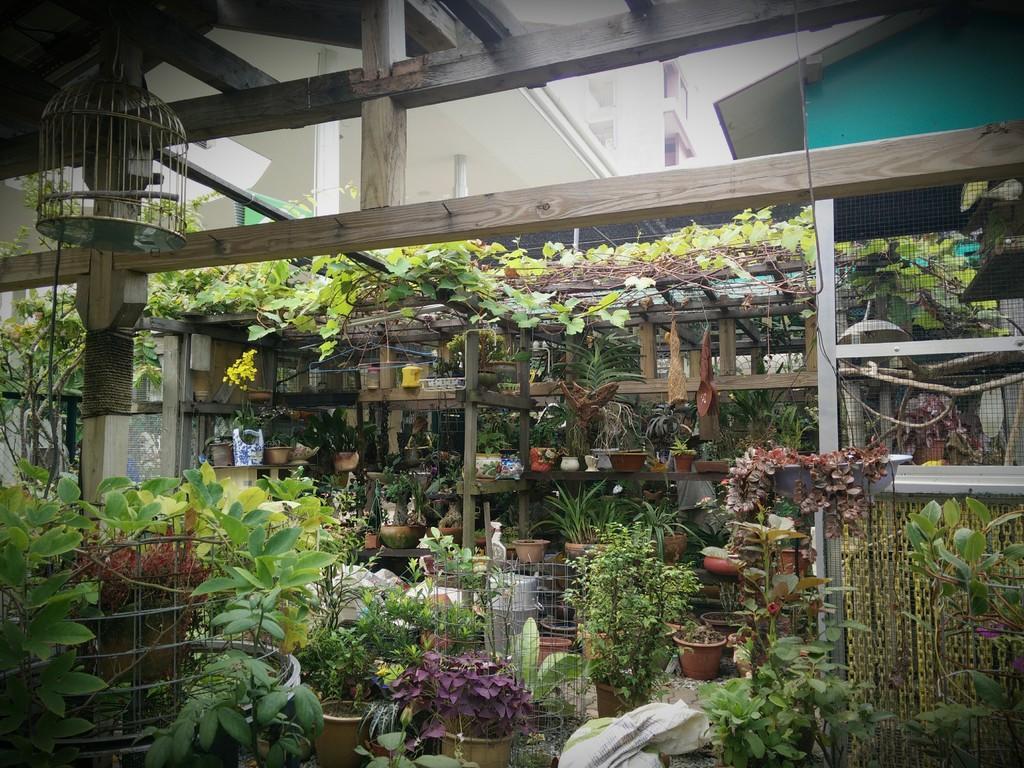Describe this image in one or two sentences. In the picture I can see plant pots, plants, wooden shelves, a bird cage and some other objects. 